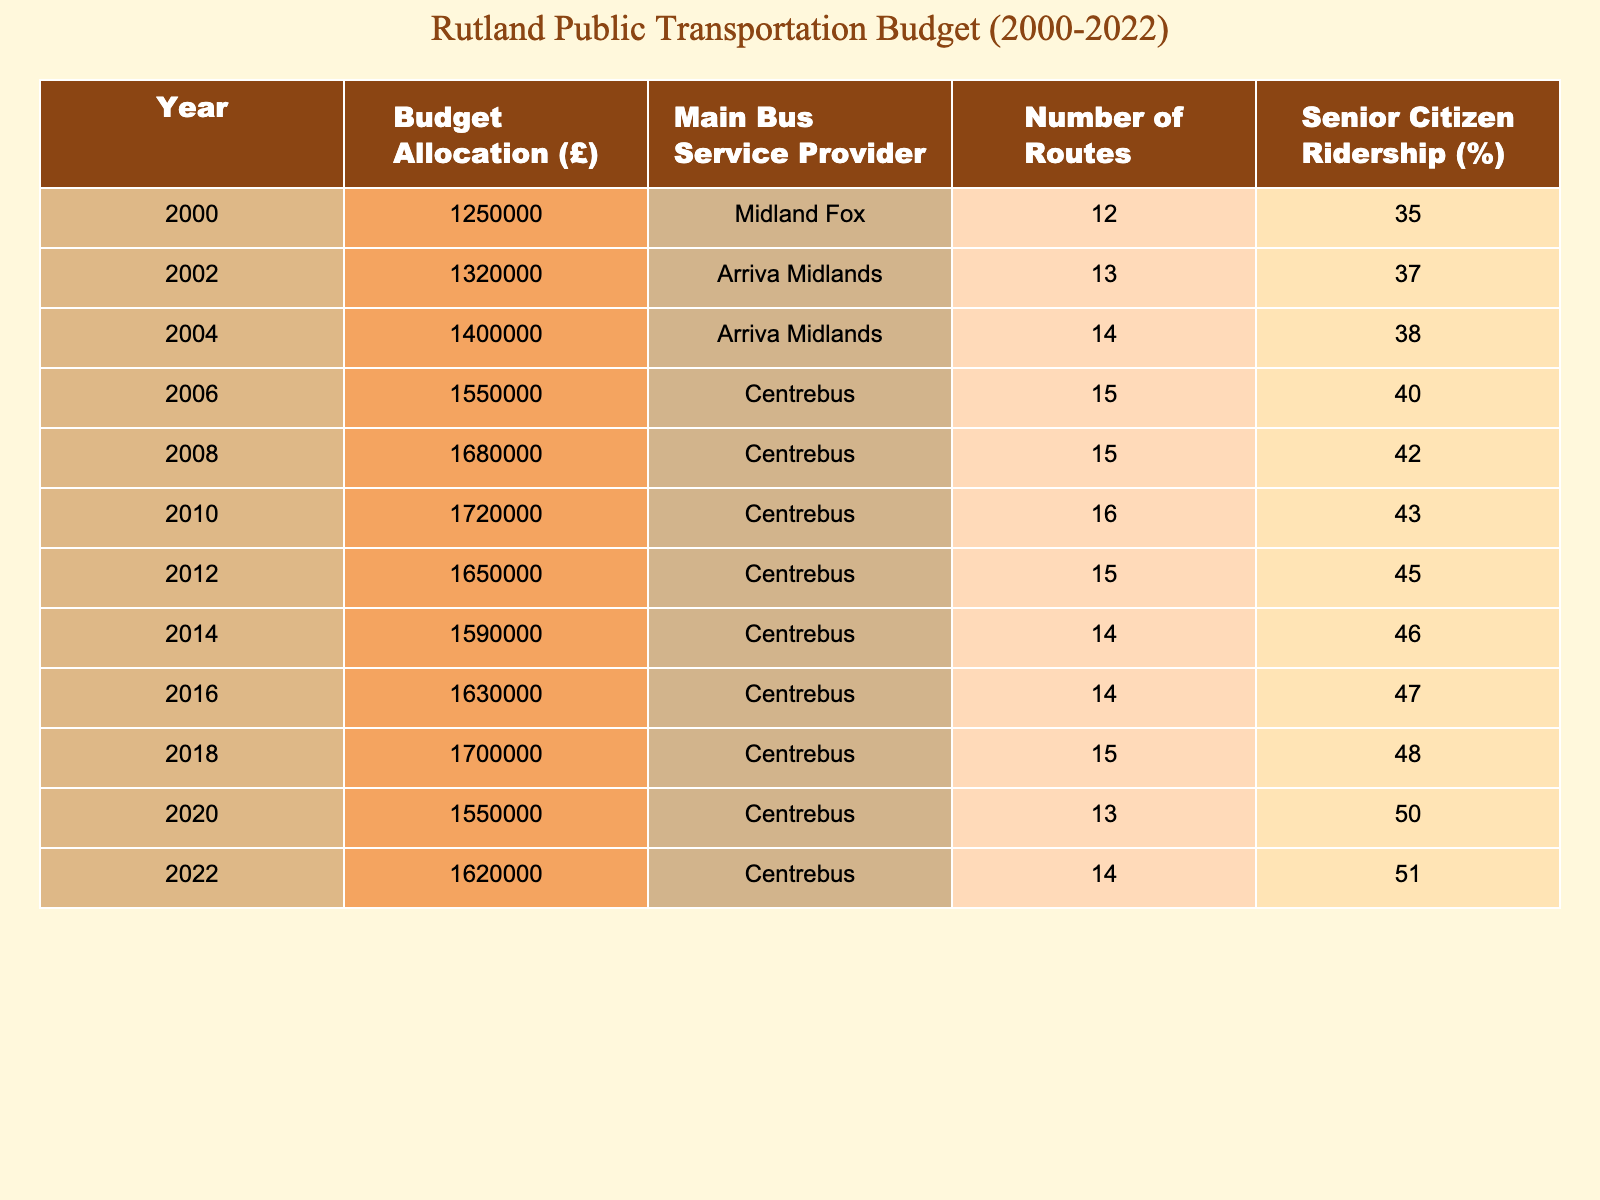What was the budget allocation for Rutland's public transportation in 2010? The table indicates that in the year 2010, the budget allocation was £1,720,000.
Answer: £1,720,000 Which bus service provider has been listed since 2004? The table shows that Arriva Midlands was the service provider in 2004 and that Centrebus has been listed from 2006 onwards.
Answer: Centrebus What was the change in budget allocation from 2000 to 2022? To find the change, subtract the budget allocation in 2000 (£1,250,000) from that in 2022 (£1,620,000): £1,620,000 - £1,250,000 = £370,000.
Answer: £370,000 What year had the highest percentage of senior citizen ridership? By scanning the column for senior citizen ridership, the table shows that the highest percentage was in the year 2022 at 51%.
Answer: 2022 What is the average budget allocation from 2000 to 2022? To find the average, sum all the budget allocations from 2000 to 2022 which totals £20,731,000, then divide by the number of data points (11 years): £20,731,000 / 11 = £1,884,636.36.
Answer: £1,884,636.36 Did the number of routes increase every year from 2000 to 2022? Checking the column for the number of routes shows fluctuations, as the number of routes decreased from 16 in 2010 to 14 in 2014, and then again dropped to 13 in 2020. Thus, it did not increase every year.
Answer: No Which year experienced the smallest budget allocation? The table reveals that the smallest budget allocation was in 2000, with £1,250,000 allocated.
Answer: £1,250,000 How many more routes did the bus service have in 2012 compared to 2014? In 2012, there were 15 routes, while in 2014 there were 14 routes. Therefore, the difference is 15 - 14 = 1 route.
Answer: 1 route What year saw the biggest increase in budget allocation compared to the previous year? Analyzing the increments, the largest jump occurred from 2008 (£1,680,000) to 2010 (£1,720,000), which is an increase of £40,000.
Answer: £40,000 What was the bus service provider in 2006 and what percentage of senior citizen ridership was reported that year? The table indicates that the bus service provider in 2006 was Centrebus and the senior citizen ridership was 40%.
Answer: Centrebus, 40% 